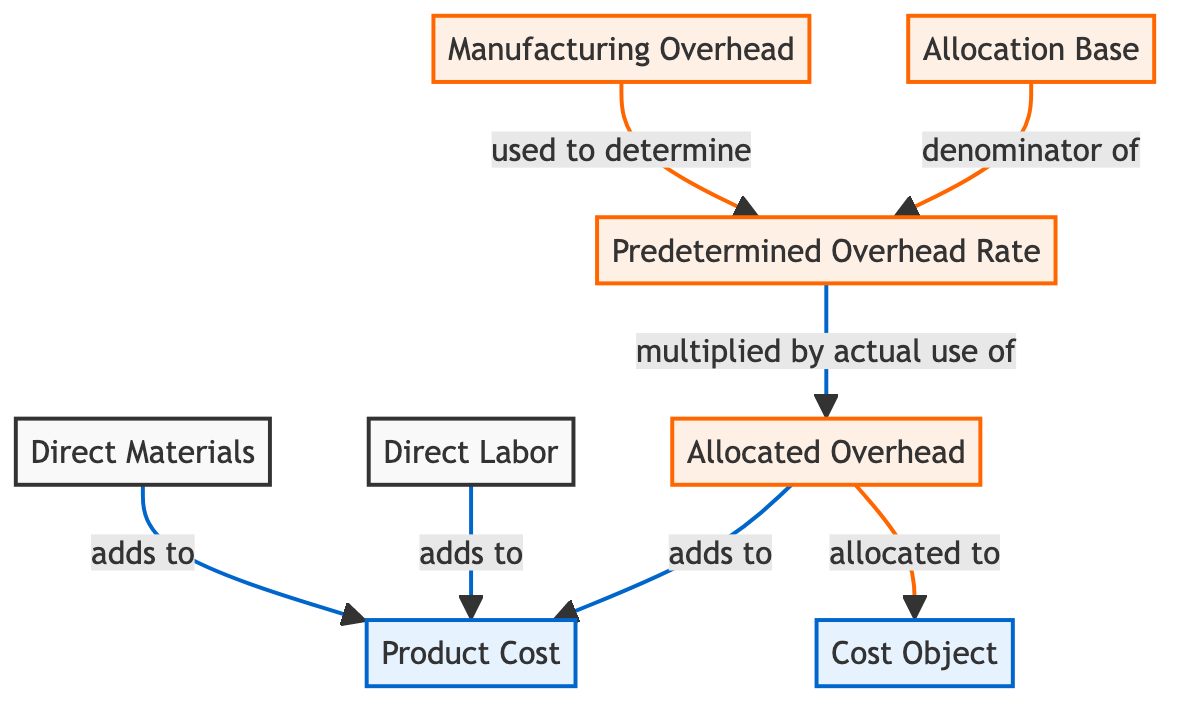What's the number of nodes in the diagram? The diagram consists of six unique nodes labeled Direct Materials, Direct Labor, Manufacturing Overhead, Product Cost, Allocation Base, and Cost Object. Counting each of these gives a total of six nodes.
Answer: 6 What connects Manufacturing Overhead to Predetermined Overhead Rate? The arrow labeled "used to determine" connects Manufacturing Overhead to Predetermined Overhead Rate, indicating that the manufacturing overhead is a crucial factor in calculating the predetermined overhead rate.
Answer: used to determine What does Allocation Base represent in the diagram? Allocation Base is shown as the denominator for the Predetermined Overhead Rate, which is crucial for calculating overhead allocation.
Answer: denominator of Which elements contribute to Product Cost? Product Cost is formed by adding Direct Materials, Direct Labor, and Allocated Overhead. Thus, all three elements contribute to the total product cost.
Answer: Direct Materials, Direct Labor, Allocated Overhead How is Allocated Overhead calculated in the diagram? Allocated Overhead is derived by multiplying the Predetermined Overhead Rate with the actual use, indicating that it directly depends on both of these components for its calculation.
Answer: multiplied by actual use of What is the relationship between Allocated Overhead and Cost Object? Allocated Overhead is allocated to Cost Object, meaning that the overhead costs assigned based on the predetermined rate are directly applied to this cost object in the diagram.
Answer: allocated to How many arrows are involved in the relationship between Product Cost and its contributors? There are three arrows leading into Product Cost from Direct Materials, Direct Labor, and Allocated Overhead, indicating these three contributors to the overall product cost.
Answer: 3 What is the purpose of Predetermined Overhead Rate in the diagram? The purpose of Predetermined Overhead Rate is to provide a framework for determining the amount of overhead that should be applied to a given cost object based on its allocated base.
Answer: to determine overhead allocation What purpose does the flowchart serve in understanding cost accounting techniques? The flowchart visually illustrates the relationships and processes involved in calculating product costs and overhead allocation, aiding in the understanding of these cost accounting techniques.
Answer: visualize relationships and processes 